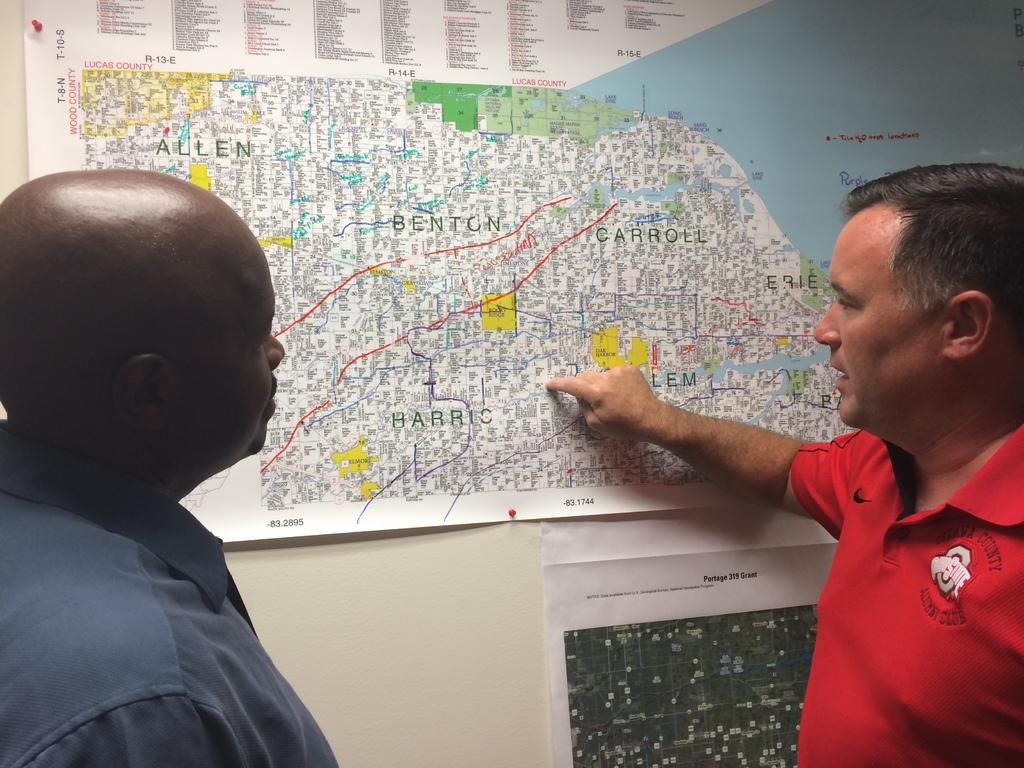How many people are present in the image? There are two men standing in the image. What can be seen in the background of the image? There is a wall in the background of the image. What is on the wall in the image? There is a map on the wall. What type of polish is being applied to the veins in the image? There is no polish or veins present in the image; it features two men standing in front of a wall with a map. 